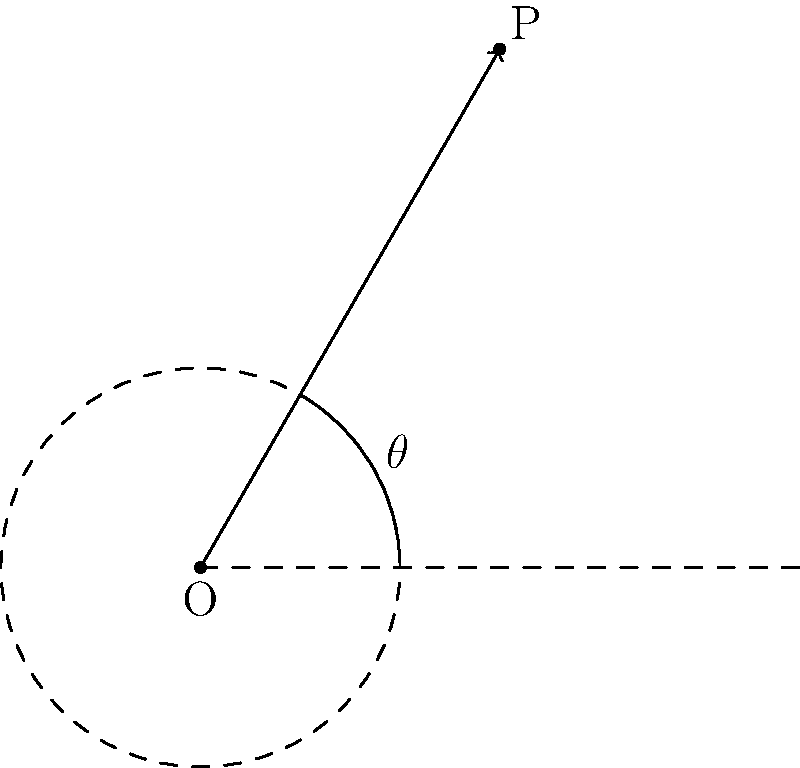In an antenna radiation pattern analysis, you encounter a signal strength measurement given in polar coordinates as $(r, \theta) = (3, 60°)$. To integrate this data with your rectangular coordinate system analysis tools, you need to convert it. What are the equivalent rectangular coordinates $(x, y)$ for this measurement? To convert polar coordinates $(r, \theta)$ to rectangular coordinates $(x, y)$, we use the following formulas:

1) $x = r \cos(\theta)$
2) $y = r \sin(\theta)$

Given:
- $r = 3$
- $\theta = 60°$

Step 1: Calculate x
$x = r \cos(\theta)$
$x = 3 \cos(60°)$
$x = 3 \cdot \frac{1}{2} = 1.5$

Step 2: Calculate y
$y = r \sin(\theta)$
$y = 3 \sin(60°)$
$y = 3 \cdot \frac{\sqrt{3}}{2} = 1.5\sqrt{3} \approx 2.598$

Therefore, the rectangular coordinates are approximately $(1.5, 2.598)$.

Note: As a retired electronic repair technician, you understand the importance of precise measurements. In practical applications, you might round these values to a certain number of decimal places depending on the required precision of your antenna analysis tools.
Answer: $(1.5, 2.598)$ 